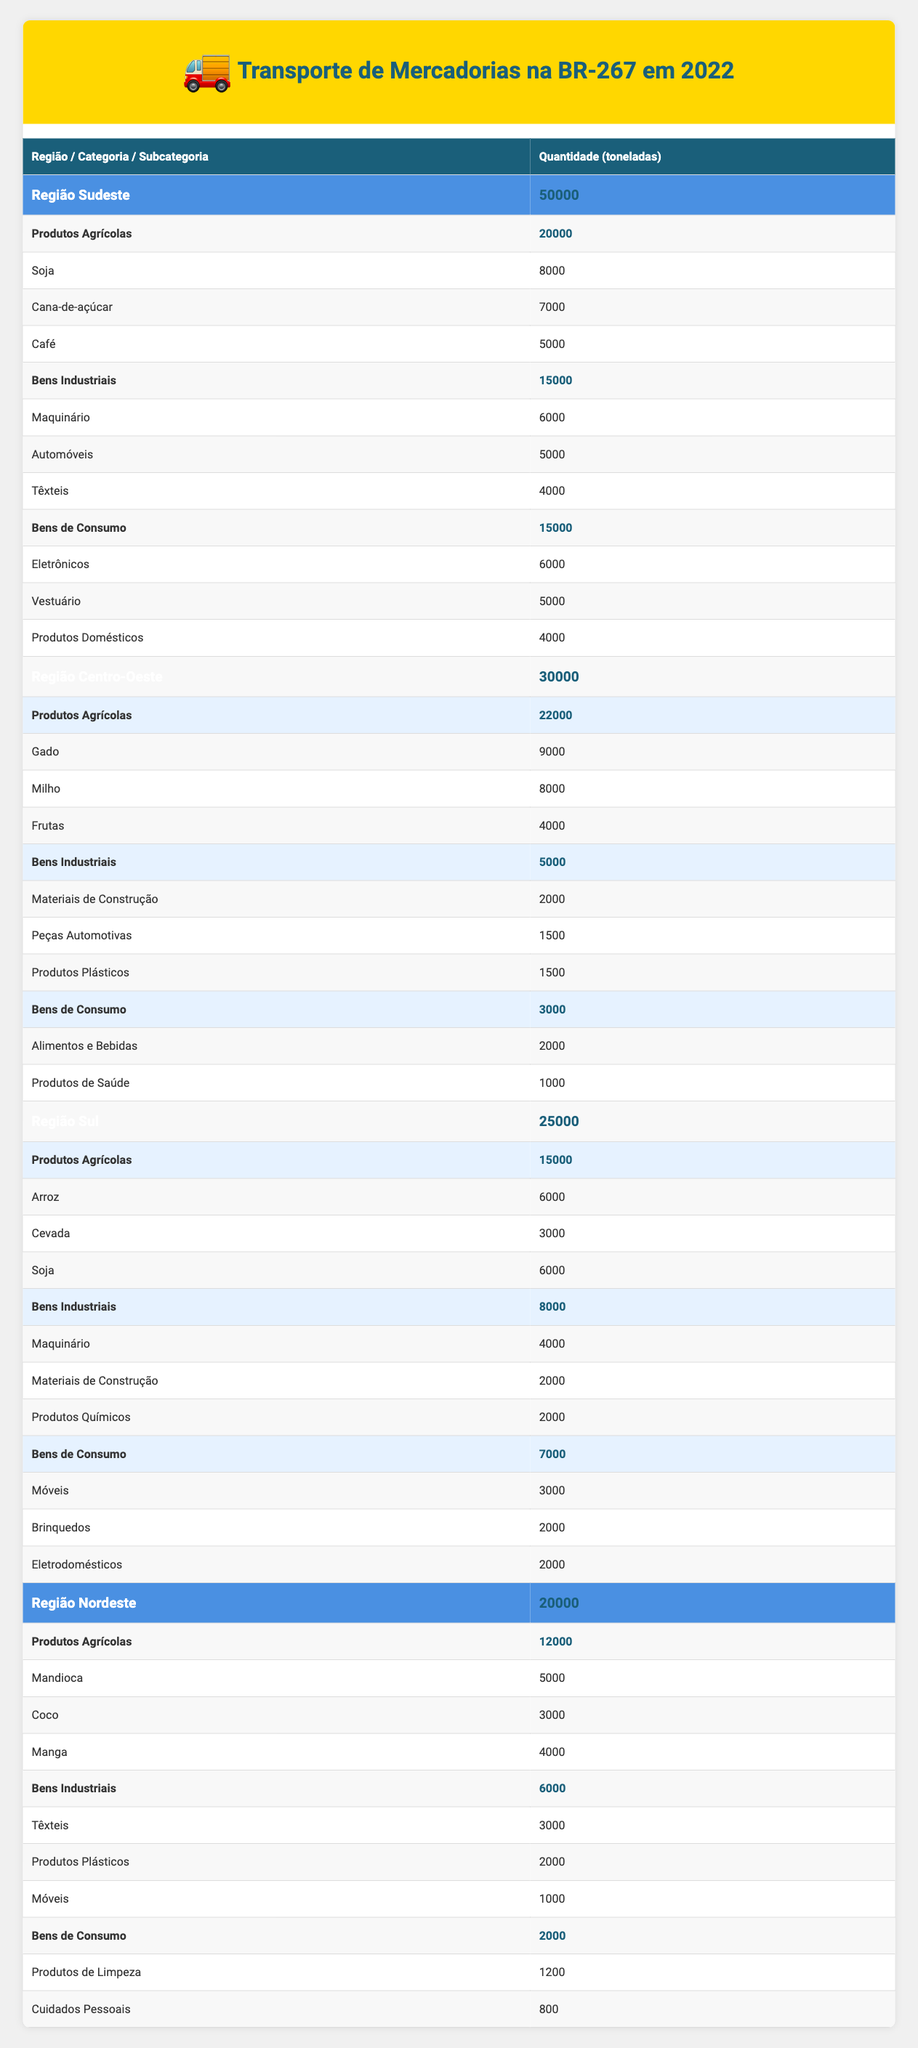What is the total amount of goods transported in the Southeast Region? From the table, we can see that the total goods transported in the Southeast Region is listed as 50,000 tons.
Answer: 50,000 tons How many tons of Agricultural Products were transported in the Center-West Region? The Center-West Region category shows that the total for Agricultural Products is 22,000 tons.
Answer: 22,000 tons Which region transported the least amount of goods? Comparing the total goods transported across all regions, the Northeast Region has 20,000 tons, which is less than all other regions.
Answer: Northeast Region What is the combined total of Consumer Goods transported across all regions? The total of Consumer Goods comes from each region: Southeast (15,000) + Center-West (3,000) + South (7,000) + Northeast (2,000) = 27,000 tons.
Answer: 27,000 tons Did the South Region transport more Industrial Goods than the Center-West Region? The South Region transported 8,000 tons of Industrial Goods, while the Center-West Region transported 5,000 tons; therefore, the South Region did transport more.
Answer: Yes Which category had the highest transportation volume in the Southeast Region? In the Southeast Region, Agricultural Products has a total of 20,000 tons, which is more than Industrial Goods (15,000) and Consumer Goods (15,000).
Answer: Agricultural Products What is the total amount of goods transported in the South Region, and how does it compare to the Northeast Region? The South Region transported 25,000 tons, and the Northeast Region transported 20,000 tons, making the South Region 5,000 tons higher.
Answer: 25,000 tons, South Region is higher How many tons of Soybeans were transported across all regions? The total for Soybeans includes the Southeast Region (8,000), South Region (6,000), and no Soybeans listed for Center-West and Northeast. Thus, the total is 14,000 tons.
Answer: 14,000 tons What percentage of total goods transported in the Southeast Region were Agricultural Products? The total goods transported in the Southeast is 50,000 tons, and Agricultural Products are 20,000 tons. The percentage is (20,000 / 50,000) * 100 = 40%.
Answer: 40% 